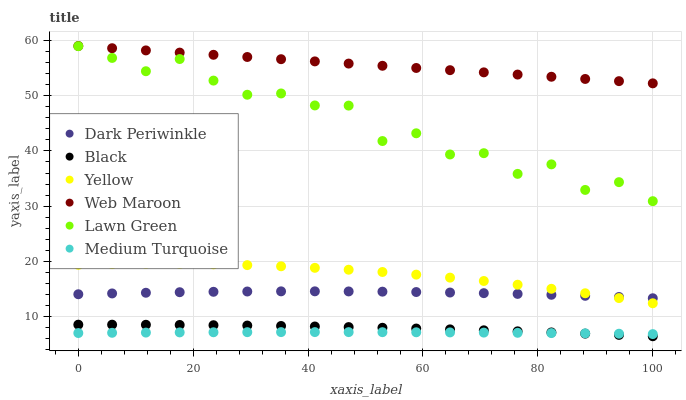Does Medium Turquoise have the minimum area under the curve?
Answer yes or no. Yes. Does Web Maroon have the maximum area under the curve?
Answer yes or no. Yes. Does Yellow have the minimum area under the curve?
Answer yes or no. No. Does Yellow have the maximum area under the curve?
Answer yes or no. No. Is Web Maroon the smoothest?
Answer yes or no. Yes. Is Lawn Green the roughest?
Answer yes or no. Yes. Is Yellow the smoothest?
Answer yes or no. No. Is Yellow the roughest?
Answer yes or no. No. Does Black have the lowest value?
Answer yes or no. Yes. Does Yellow have the lowest value?
Answer yes or no. No. Does Web Maroon have the highest value?
Answer yes or no. Yes. Does Yellow have the highest value?
Answer yes or no. No. Is Medium Turquoise less than Web Maroon?
Answer yes or no. Yes. Is Web Maroon greater than Black?
Answer yes or no. Yes. Does Black intersect Medium Turquoise?
Answer yes or no. Yes. Is Black less than Medium Turquoise?
Answer yes or no. No. Is Black greater than Medium Turquoise?
Answer yes or no. No. Does Medium Turquoise intersect Web Maroon?
Answer yes or no. No. 